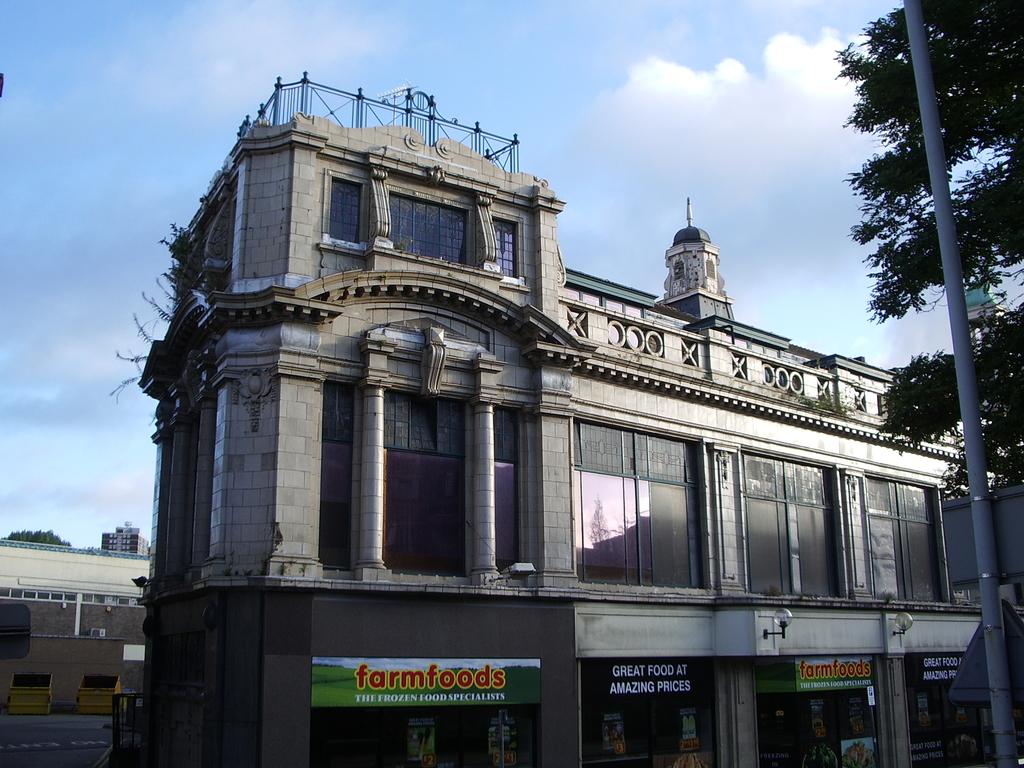What is the name of the first local to the left?
Make the answer very short. Farmfoods. Great foor at what kind of prices?
Provide a succinct answer. Amazing. 